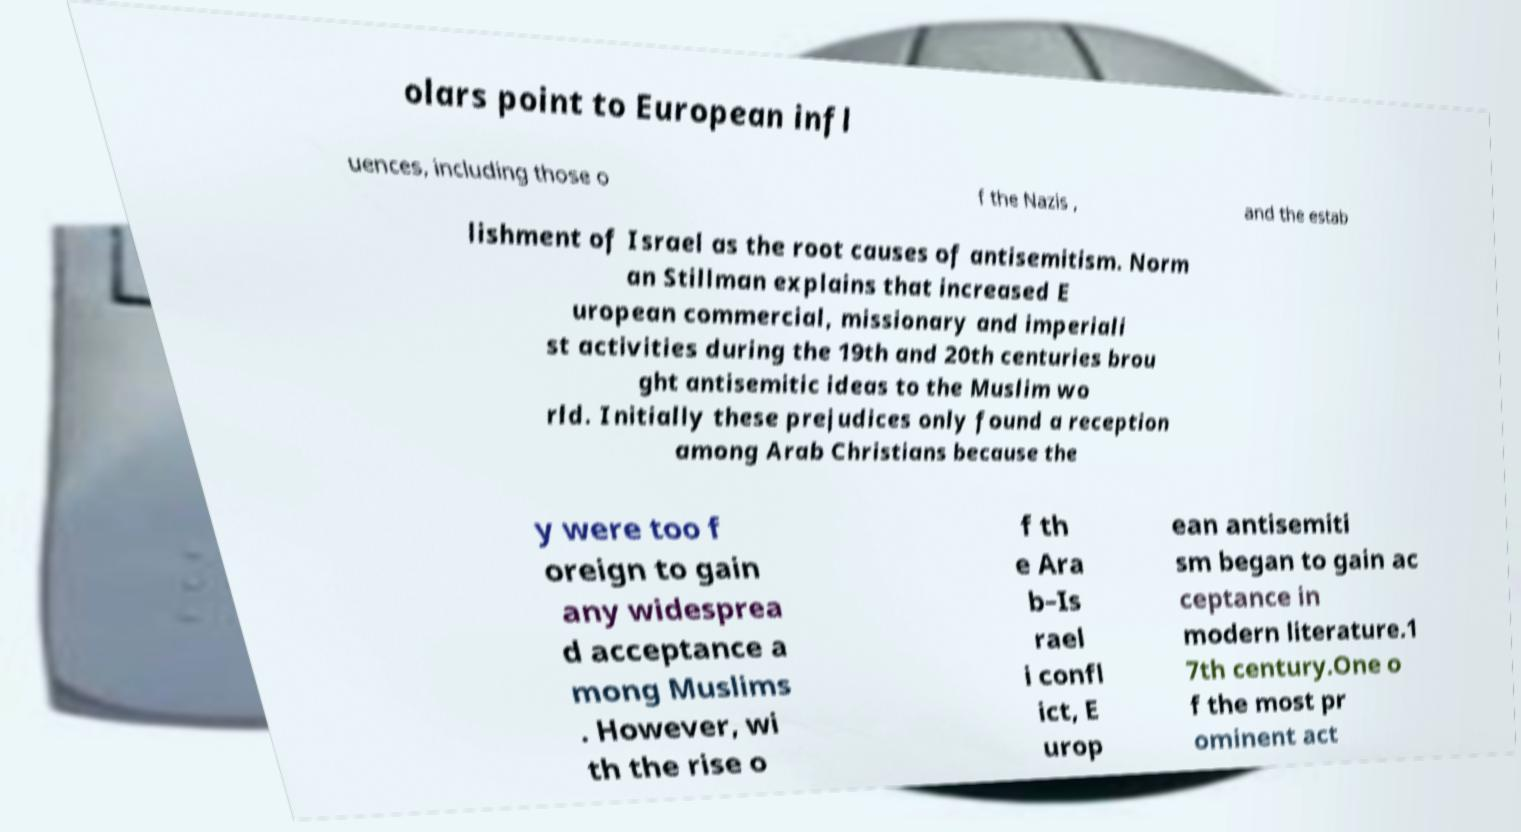Can you read and provide the text displayed in the image?This photo seems to have some interesting text. Can you extract and type it out for me? olars point to European infl uences, including those o f the Nazis , and the estab lishment of Israel as the root causes of antisemitism. Norm an Stillman explains that increased E uropean commercial, missionary and imperiali st activities during the 19th and 20th centuries brou ght antisemitic ideas to the Muslim wo rld. Initially these prejudices only found a reception among Arab Christians because the y were too f oreign to gain any widesprea d acceptance a mong Muslims . However, wi th the rise o f th e Ara b–Is rael i confl ict, E urop ean antisemiti sm began to gain ac ceptance in modern literature.1 7th century.One o f the most pr ominent act 